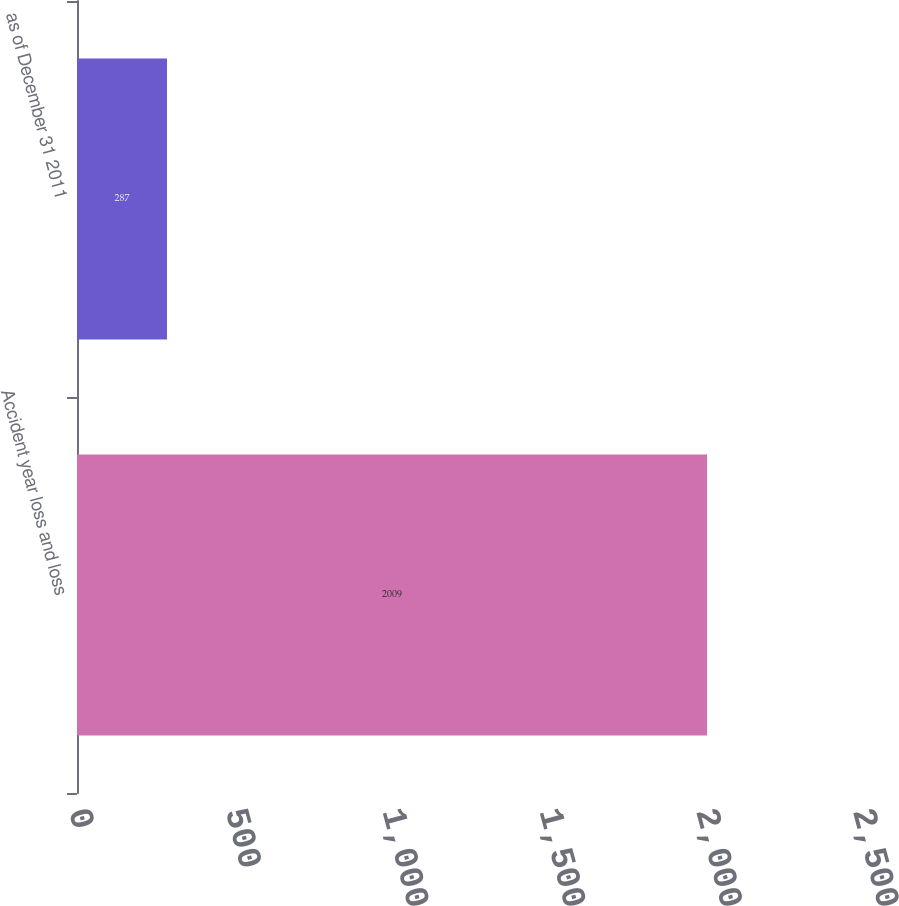Convert chart. <chart><loc_0><loc_0><loc_500><loc_500><bar_chart><fcel>Accident year loss and loss<fcel>as of December 31 2011<nl><fcel>2009<fcel>287<nl></chart> 